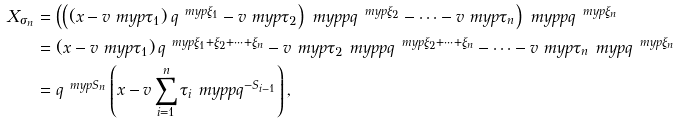Convert formula to latex. <formula><loc_0><loc_0><loc_500><loc_500>X _ { \sigma _ { n } } & = \left ( \left ( ( x - v \ m y p \tau _ { 1 } ) \, q ^ { \ m y p \xi _ { 1 } } - v \ m y p \tau _ { 2 } \right ) \ m y p p q ^ { \ m y p \xi _ { 2 } } - \dots - v \ m y p \tau _ { n } \right ) \ m y p p q ^ { \ m y p \xi _ { n } } \\ & = ( x - v \ m y p \tau _ { 1 } ) \, q ^ { \ m y p \xi _ { 1 } + \xi _ { 2 } + \dots + \xi _ { n } } - v \ m y p \tau _ { 2 } \ m y p p q ^ { \ m y p \xi _ { 2 } + \dots + \xi _ { n } } - \dots - v \ m y p \tau _ { n } \ m y p q ^ { \ m y p \xi _ { n } } \\ & = q ^ { \ m y p S _ { n } } \left ( x - v \sum _ { i = 1 } ^ { n } \tau _ { i } \ m y p p q ^ { - S _ { i - 1 } } \right ) ,</formula> 